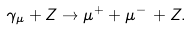<formula> <loc_0><loc_0><loc_500><loc_500>\gamma _ { \mu } + Z \to \mu ^ { + } + \mu ^ { - } \, + Z .</formula> 